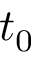<formula> <loc_0><loc_0><loc_500><loc_500>t _ { 0 }</formula> 